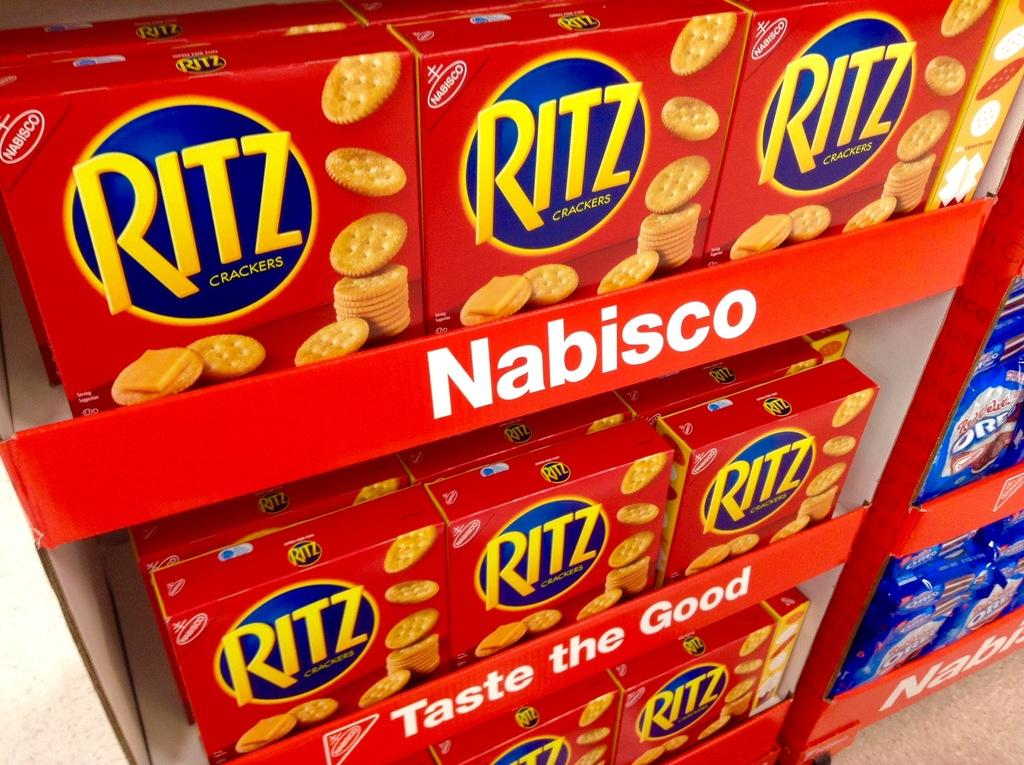What is present in the image? There are food products in the image. How are the food products arranged? The food products are placed on racks. Is there any text visible in the image? Yes, there is text in the image. What type of leather can be seen in the image? There is no leather present in the image. What color are the crayons in the image? There are no crayons present in the image. 